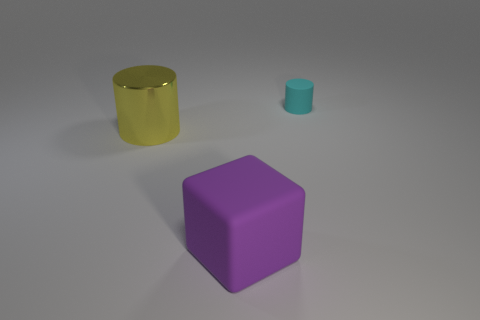Add 3 red shiny cylinders. How many objects exist? 6 Subtract 0 green cylinders. How many objects are left? 3 Subtract all cubes. How many objects are left? 2 Subtract all yellow cylinders. Subtract all yellow cylinders. How many objects are left? 1 Add 3 big yellow metal things. How many big yellow metal things are left? 4 Add 3 small green cubes. How many small green cubes exist? 3 